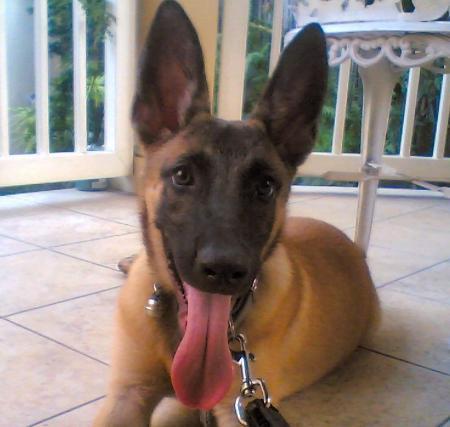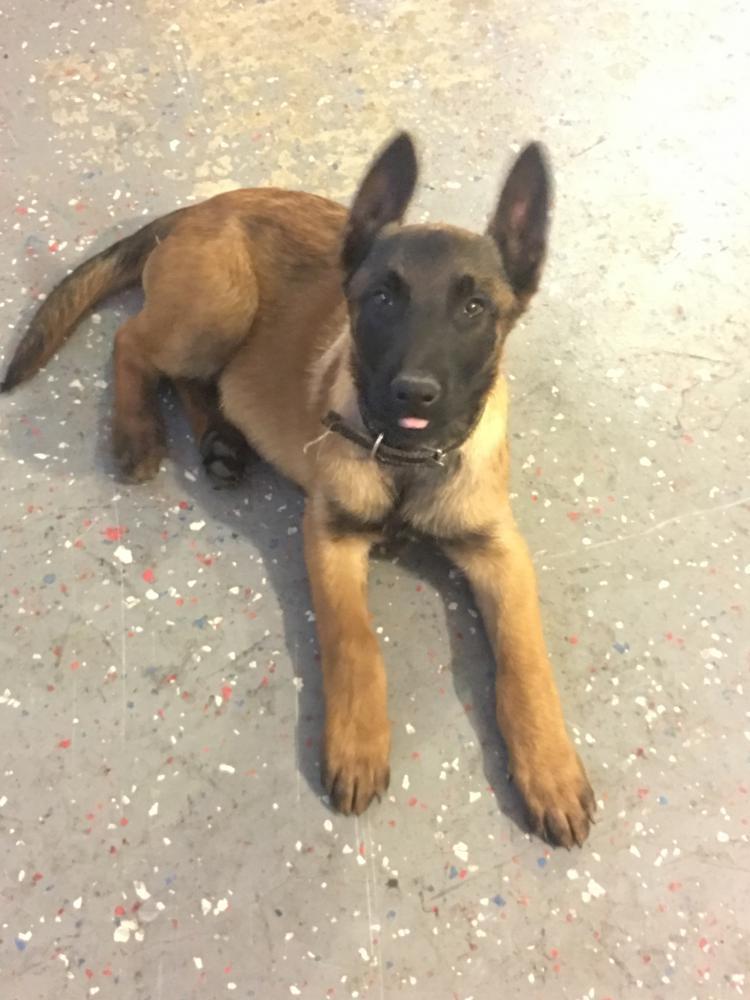The first image is the image on the left, the second image is the image on the right. Examine the images to the left and right. Is the description "Each image contains one german shepherd, and the right image shows a dog moving toward the lower left." accurate? Answer yes or no. No. The first image is the image on the left, the second image is the image on the right. Evaluate the accuracy of this statement regarding the images: "In one of the images, the dog is on a tile floor.". Is it true? Answer yes or no. Yes. 